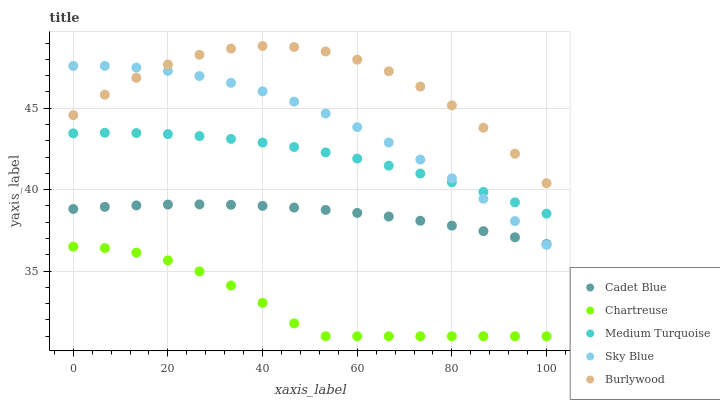Does Chartreuse have the minimum area under the curve?
Answer yes or no. Yes. Does Burlywood have the maximum area under the curve?
Answer yes or no. Yes. Does Sky Blue have the minimum area under the curve?
Answer yes or no. No. Does Sky Blue have the maximum area under the curve?
Answer yes or no. No. Is Cadet Blue the smoothest?
Answer yes or no. Yes. Is Burlywood the roughest?
Answer yes or no. Yes. Is Sky Blue the smoothest?
Answer yes or no. No. Is Sky Blue the roughest?
Answer yes or no. No. Does Chartreuse have the lowest value?
Answer yes or no. Yes. Does Sky Blue have the lowest value?
Answer yes or no. No. Does Burlywood have the highest value?
Answer yes or no. Yes. Does Sky Blue have the highest value?
Answer yes or no. No. Is Chartreuse less than Cadet Blue?
Answer yes or no. Yes. Is Burlywood greater than Cadet Blue?
Answer yes or no. Yes. Does Sky Blue intersect Medium Turquoise?
Answer yes or no. Yes. Is Sky Blue less than Medium Turquoise?
Answer yes or no. No. Is Sky Blue greater than Medium Turquoise?
Answer yes or no. No. Does Chartreuse intersect Cadet Blue?
Answer yes or no. No. 